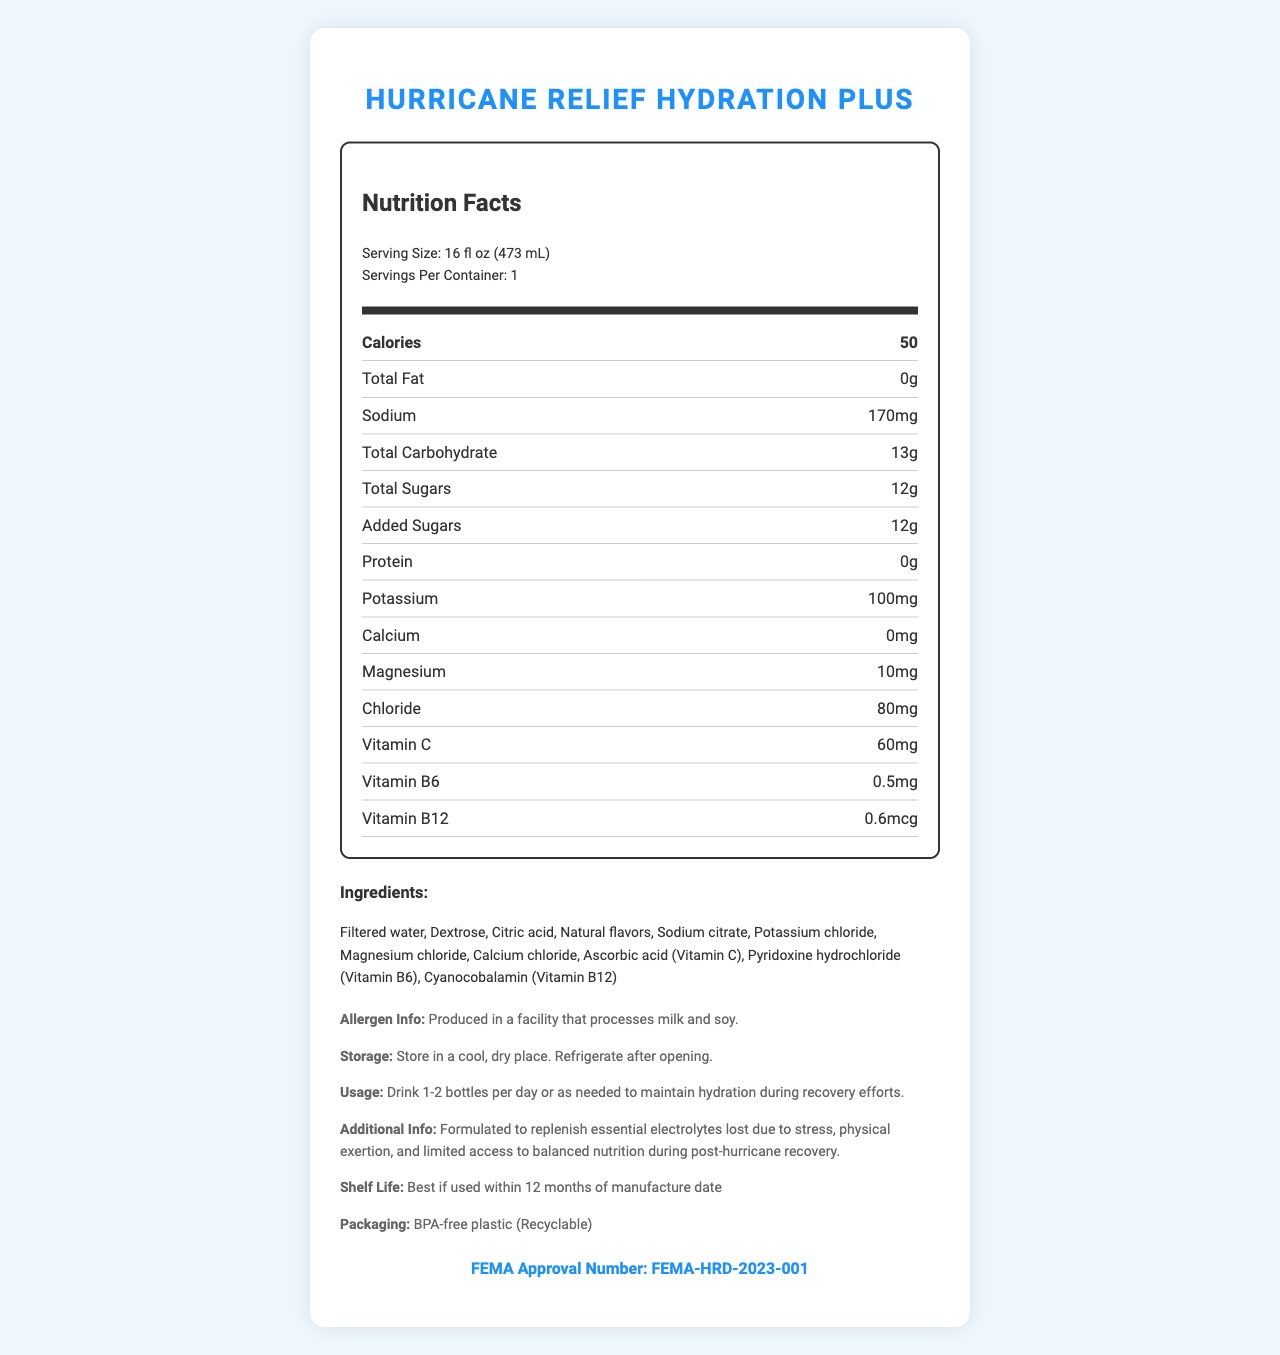what is the serving size of Hurricane Relief Hydration Plus? The serving size is stated as "Serving Size: 16 fl oz (473 mL)" under the nutrition header.
Answer: 16 fl oz (473 mL) How many calories are in one serving of Hurricane Relief Hydration Plus? The document explicitly lists "Calories: 50" under the nutrition section.
Answer: 50 What is the content of sodium per serving? Under the nutrition section, sodium content is listed as "Sodium: 170mg".
Answer: 170mg List two vitamins included in Hurricane Relief Hydration Plus. The vitamins listed in the nutrition section include Vitamin C (60mg) and Vitamin B6 (0.5mg).
Answer: Vitamin C, Vitamin B6 What is the shelf life of Hurricane Relief Hydration Plus? The shelf life information is stated in the additional info section as "Shelf Life: Best if used within 12 months of manufacture date".
Answer: Best if used within 12 months of manufacture date What is the amount of magnesium in Hurricane Relief Hydration Plus? The amount of magnesium is listed as "Magnesium: 10mg" in the nutrition section.
Answer: 10mg Which of the following ingredients is NOT listed in Hurricane Relief Hydration Plus? A. Dextrose B. Citric Acid C. Stevia D. Sodium Citrate Stevia is not mentioned in the list of ingredients provided.
Answer: C. Stevia Where can Hurricane Relief Hydration Plus be obtained during a hurricane relief effort? A. Supermarkets B. Convenience stores C. FEMA and Red Cross centers D. Online stores The document states "Distributed by FEMA and Red Cross at hurricane relief centers" in the distribution info section.
Answer: C. FEMA and Red Cross centers Is the packaging material of Hurricane Relief Hydration Plus recyclable? The packaging is noted as "Recyclable" in the additional info section.
Answer: Yes Summarize the document of Hurricane Relief Hydration Plus. The document outlines the nutritional information, essential vitamins and minerals content, ingredients, allergen information, storage instructions, usage instructions, additional info, shelf life, packaging material, and distribution details.
Answer: Hurricane Relief Hydration Plus is a hydration beverage designed to replenish essential electrolytes during post-hurricane recovery. Each 16 fl oz bottle provides 50 calories, 170mg sodium, 13g carbohydrates, and various vitamins and minerals. It contains ingredients like filtered water, dextrose, and natural flavors, and has a recyclable BPA-free plastic packaging. This product is distributed by FEMA and Red Cross at relief centers. What is the total amount of added sugars in Hurricane Relief Hydration Plus? The document lists "Added Sugars: 12g" in the nutrition section.
Answer: 12g Can you determine the price of Hurricane Relief Hydration Plus from the document? The document does not provide any information regarding the price of Hurricane Relief Hydration Plus.
Answer: Cannot be determined 